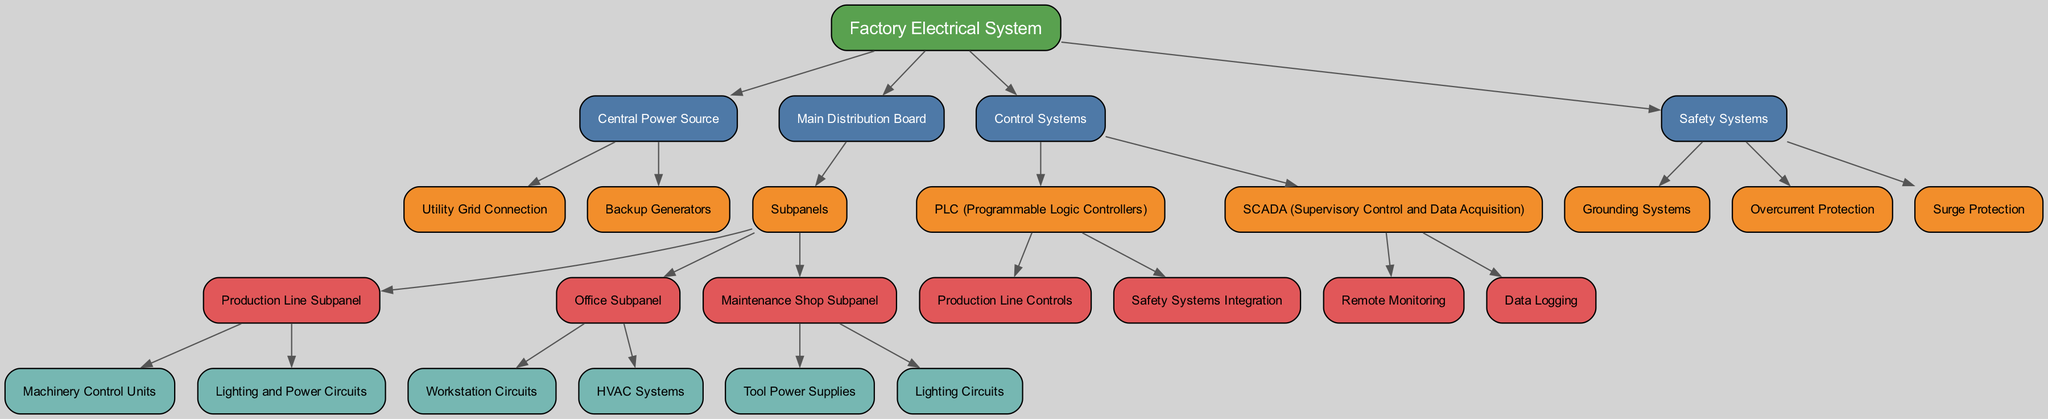What is the top-level node in the hierarchy? The top-level node is the first item in the hierarchy structure, which represents the overarching concept being illustrated. In this case, it is "Factory Electrical System".
Answer: Factory Electrical System How many main categories does the "Factory Electrical System" have? The main categories under the "Factory Electrical System" can be found as direct children of that node. There are four categories: "Central Power Source", "Main Distribution Board", "Control Systems", and "Safety Systems".
Answer: 4 Which node is responsible for handling machinery control? The node that is responsible for handling machinery control is "Machinery Control Units", which resides within the "Production Line Subpanel" under "Subpanels" in the "Main Distribution Board".
Answer: Machinery Control Units What are the components of the "Control Systems"? To answer this, we can look at the "Control Systems" node and identify its direct children. The components listed under "Control Systems" are "PLC (Programmable Logic Controllers)" and "SCADA (Supervisory Control and Data Acquisition)".
Answer: PLC (Programmable Logic Controllers), SCADA (Supervisory Control and Data Acquisition) How many types of protection systems are included in the "Safety Systems"? The "Safety Systems" node shows three distinct protection systems: "Grounding Systems", "Overcurrent Protection", and "Surge Protection". Counting these gives us the total.
Answer: 3 Which panel includes "HVAC Systems"? To identify where "HVAC Systems" is located, we start from the top and follow the hierarchy down to "Main Distribution Board", then to "Subpanels", and then to "Office Subpanel". "HVAC Systems" is a child of the "Office Subpanel".
Answer: Office Subpanel What is the parent of "Backup Generators"? The relationship can be traced from "Backup Generators" upwards in the hierarchy until we find its direct parent node. The parent node is "Central Power Source".
Answer: Central Power Source Which control system includes "Remote Monitoring"? By looking under the "Control Systems" node, we find that "Remote Monitoring" is a component of "SCADA (Supervisory Control and Data Acquisition)". We recognize this by identifying the children of the "SCADA" node.
Answer: SCADA (Supervisory Control and Data Acquisition) 